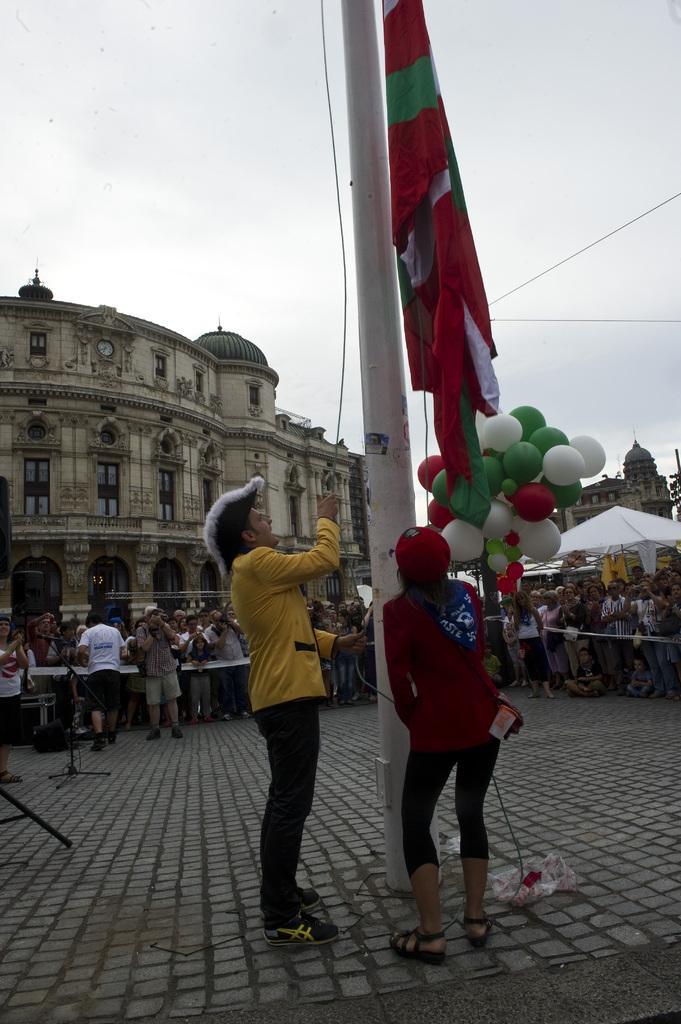Could you give a brief overview of what you see in this image? In this image we can see two persons wearing cap. One person is holding a rope and hoisting a flag on the pole. In the back there are many persons standing. Also there are balloons. And there are stands. In the background there are buildings. On the building there are windows. Also there is a clock. In the background there is sky. 